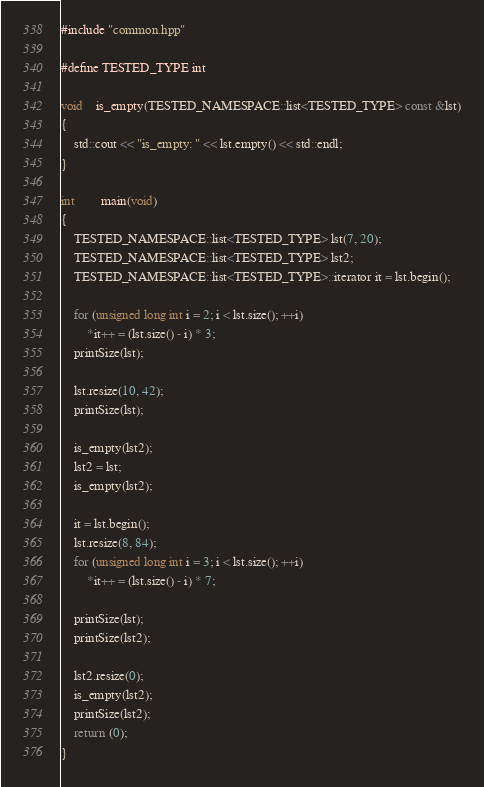<code> <loc_0><loc_0><loc_500><loc_500><_C++_>#include "common.hpp"

#define TESTED_TYPE int

void	is_empty(TESTED_NAMESPACE::list<TESTED_TYPE> const &lst)
{
	std::cout << "is_empty: " << lst.empty() << std::endl;
}

int		main(void)
{
	TESTED_NAMESPACE::list<TESTED_TYPE> lst(7, 20);
	TESTED_NAMESPACE::list<TESTED_TYPE> lst2;
	TESTED_NAMESPACE::list<TESTED_TYPE>::iterator it = lst.begin();

	for (unsigned long int i = 2; i < lst.size(); ++i)
		*it++ = (lst.size() - i) * 3;
	printSize(lst);

	lst.resize(10, 42);
	printSize(lst);

	is_empty(lst2);
	lst2 = lst;
	is_empty(lst2);

	it = lst.begin();
	lst.resize(8, 84);
	for (unsigned long int i = 3; i < lst.size(); ++i)
		*it++ = (lst.size() - i) * 7;

	printSize(lst);
	printSize(lst2);

	lst2.resize(0);
	is_empty(lst2);
	printSize(lst2);
	return (0);
}
</code> 